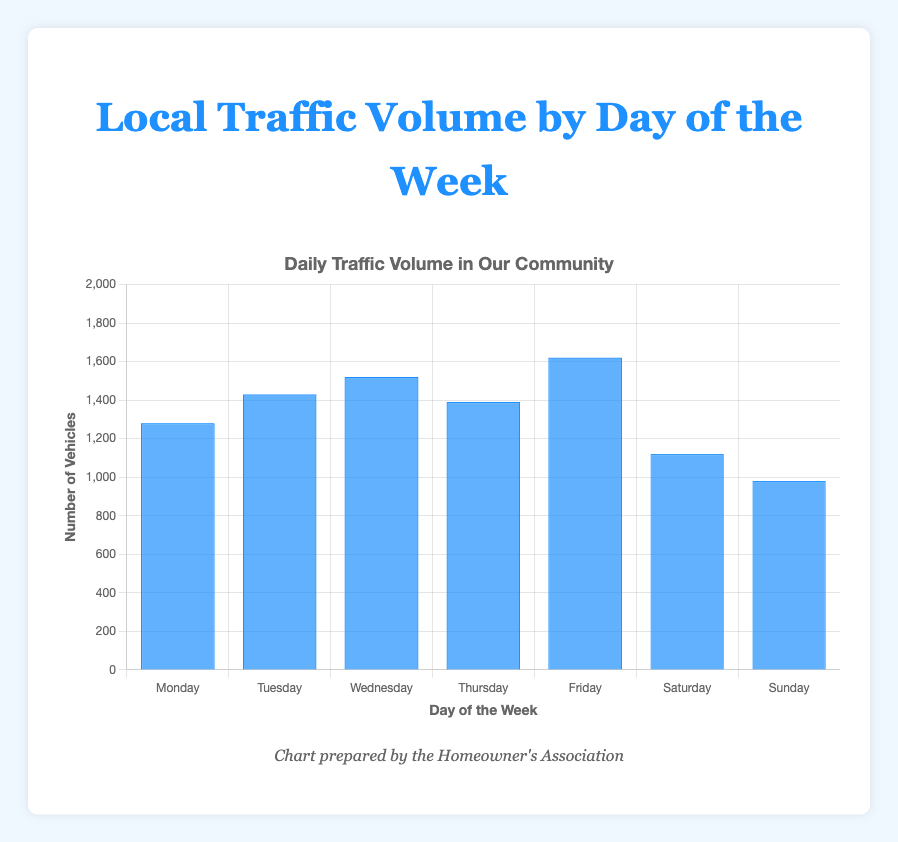Which day has the highest traffic volume? The figure shows traffic volume by day. Identify the tallest blue bar, which corresponds to Friday.
Answer: Friday Which day has the lowest traffic volume? The figure shows traffic volume by day. Identify the shortest blue bar, which corresponds to Sunday.
Answer: Sunday How much more traffic is there on Wednesday compared to Sunday? Find the bars for Wednesday (1520) and Sunday (980) in the figure. Calculate the difference: 1520 - 980.
Answer: 540 What is the average traffic volume for weekdays only (Monday to Friday)? Sum the volumes for Monday (1280), Tuesday (1430), Wednesday (1520), Thursday (1390), and Friday (1620). Calculate the average: (1280 + 1430 + 1520 + 1390 + 1620) / 5.
Answer: 1448 Is there more traffic on Thursday or Saturday? Compare the heights of the bars for Thursday (1390) and Saturday (1120). Thursday has a higher traffic volume.
Answer: Thursday What is the total traffic volume for the weekend (Saturday and Sunday)? Sum the volumes for Saturday (1120) and Sunday (980).
Answer: 2100 Which day has a traffic volume close to 1500? Identify the bar closest to 1500, which corresponds to Wednesday with a volume of 1520.
Answer: Wednesday By how much does the traffic volume increase from Monday to Friday? Find the bars for Monday (1280) and Friday (1620). Calculate the difference: 1620 - 1280.
Answer: 340 On average, how does weekend traffic compare to the average weekday traffic? Calculate the average weekend volume: (1120 + 980) / 2 = 1050. Compare it to the average weekday traffic calculated earlier (1448). The weekend average is lower.
Answer: Weekend average is lower Which days have traffic volumes exceeding 1400? Identify the bars where the traffic volumes exceed 1400, which are Tuesday (1430), Wednesday (1520), and Friday (1620).
Answer: Tuesday, Wednesday, Friday 